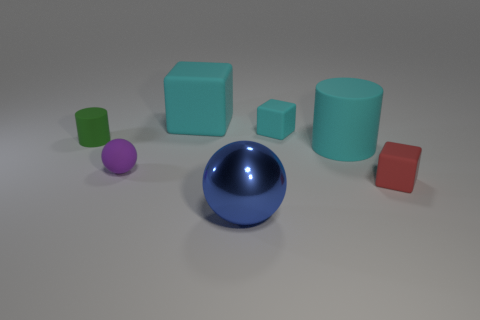If we were to categorize these objects by texture, what groups would we have? We would have two groups based on texture: glossy and matte. The glossy group includes the large blue sphere, the small red cube, and the tiny green cube, which have reflective surfaces. The matte group encompasses the teal cube, the teal cylinder, the green cylinder, and the purple sphere, all of which have non-reflective surfaces. 